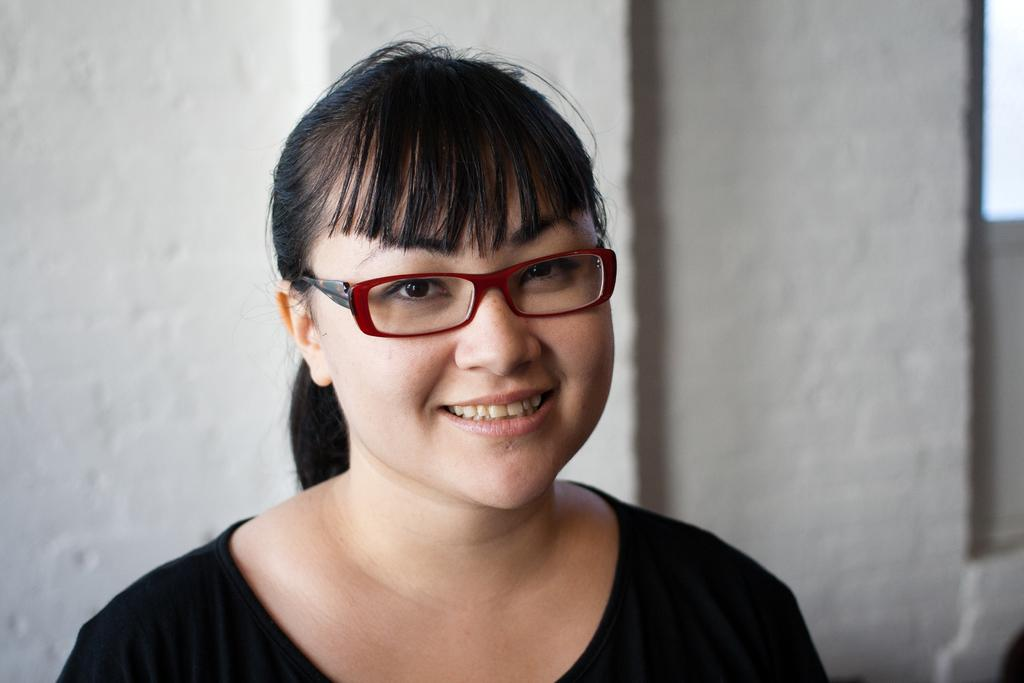Who or what is the main subject in the image? There is a person in the image. What is the person wearing? The person is wearing a black dress. Are there any accessories visible on the person? Yes, the person is wearing spectacles. What can be seen in the background of the image? There is a wall in the background of the image. Can you see any visible veins on the person's hands in the image? There is no information about the person's hands or veins in the image, so it cannot be determined. Is it raining in the image? There is no indication of rain or any weather conditions in the image. 